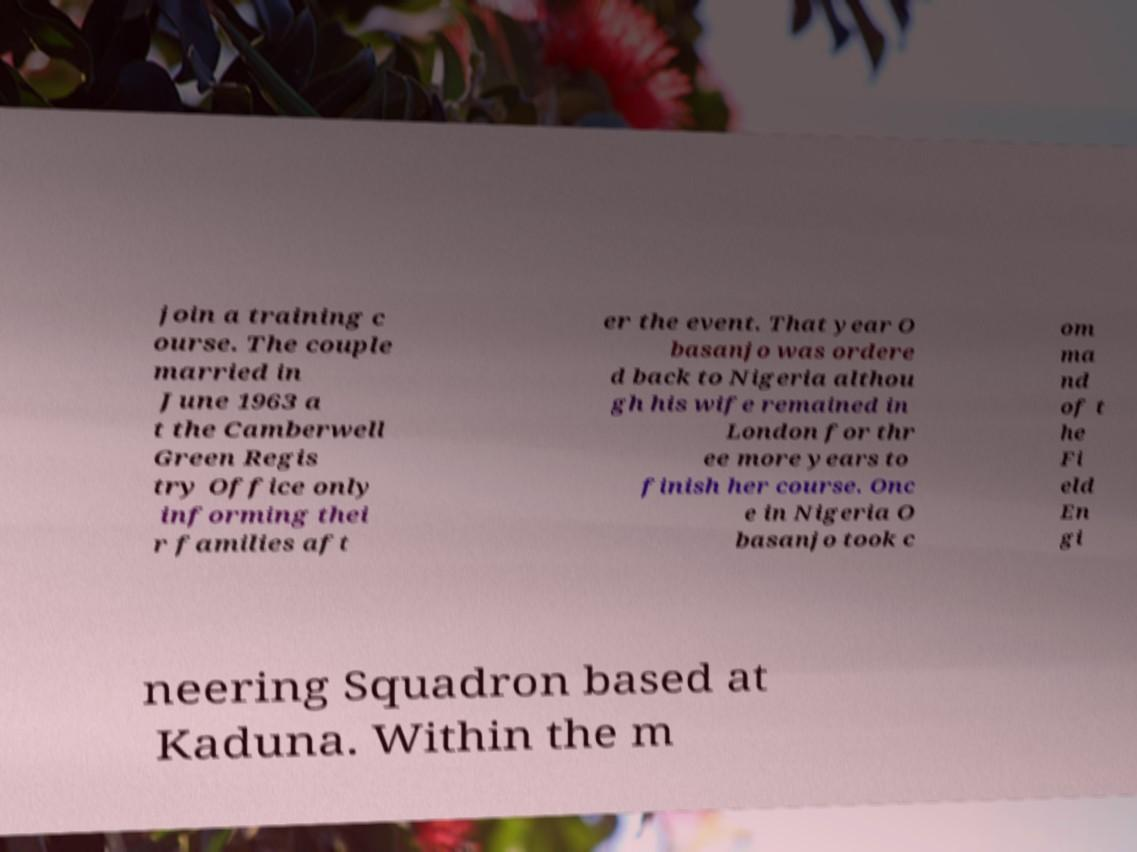Could you assist in decoding the text presented in this image and type it out clearly? join a training c ourse. The couple married in June 1963 a t the Camberwell Green Regis try Office only informing thei r families aft er the event. That year O basanjo was ordere d back to Nigeria althou gh his wife remained in London for thr ee more years to finish her course. Onc e in Nigeria O basanjo took c om ma nd of t he Fi eld En gi neering Squadron based at Kaduna. Within the m 